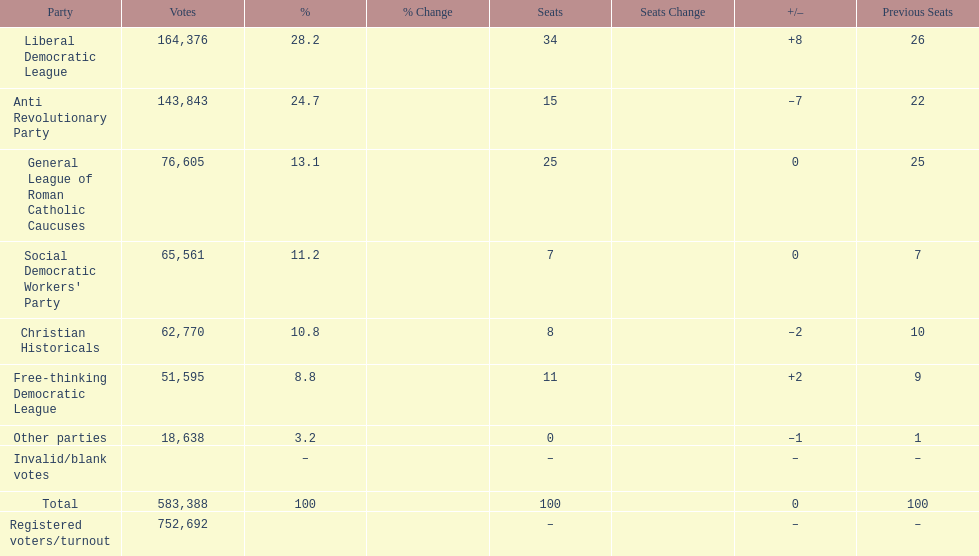After the election, how many seats did the liberal democratic league win? 34. 